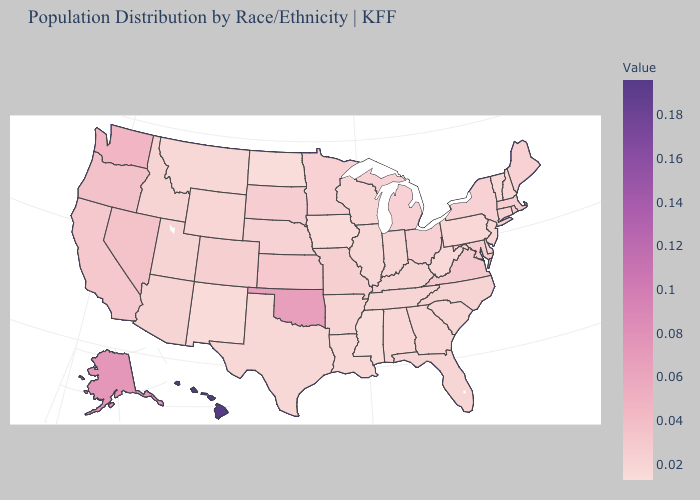Among the states that border Wyoming , which have the highest value?
Give a very brief answer. South Dakota. Among the states that border Missouri , which have the highest value?
Concise answer only. Oklahoma. Does Wyoming have a higher value than Hawaii?
Quick response, please. No. Among the states that border Wisconsin , does Illinois have the lowest value?
Short answer required. No. Does Mississippi have the lowest value in the South?
Quick response, please. Yes. 